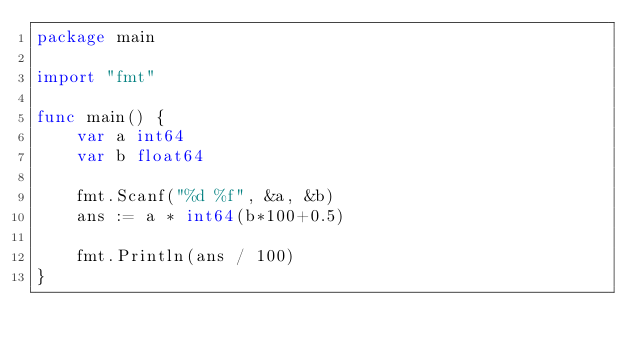<code> <loc_0><loc_0><loc_500><loc_500><_Go_>package main

import "fmt"

func main() {
	var a int64
	var b float64

	fmt.Scanf("%d %f", &a, &b)
	ans := a * int64(b*100+0.5)

	fmt.Println(ans / 100)
}</code> 